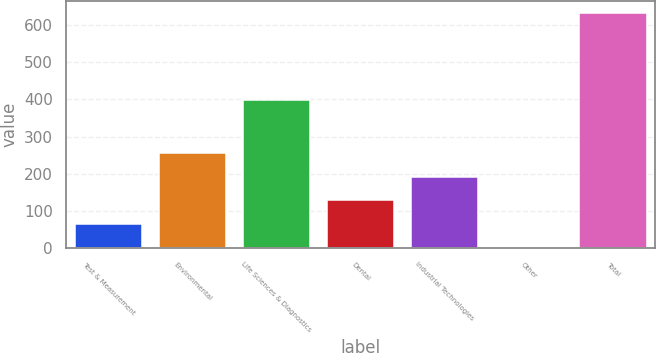Convert chart. <chart><loc_0><loc_0><loc_500><loc_500><bar_chart><fcel>Test & Measurement<fcel>Environmental<fcel>Life Sciences & Diagnostics<fcel>Dental<fcel>Industrial Technologies<fcel>Other<fcel>Total<nl><fcel>65.19<fcel>254.46<fcel>399.4<fcel>128.28<fcel>191.37<fcel>2.1<fcel>633<nl></chart> 